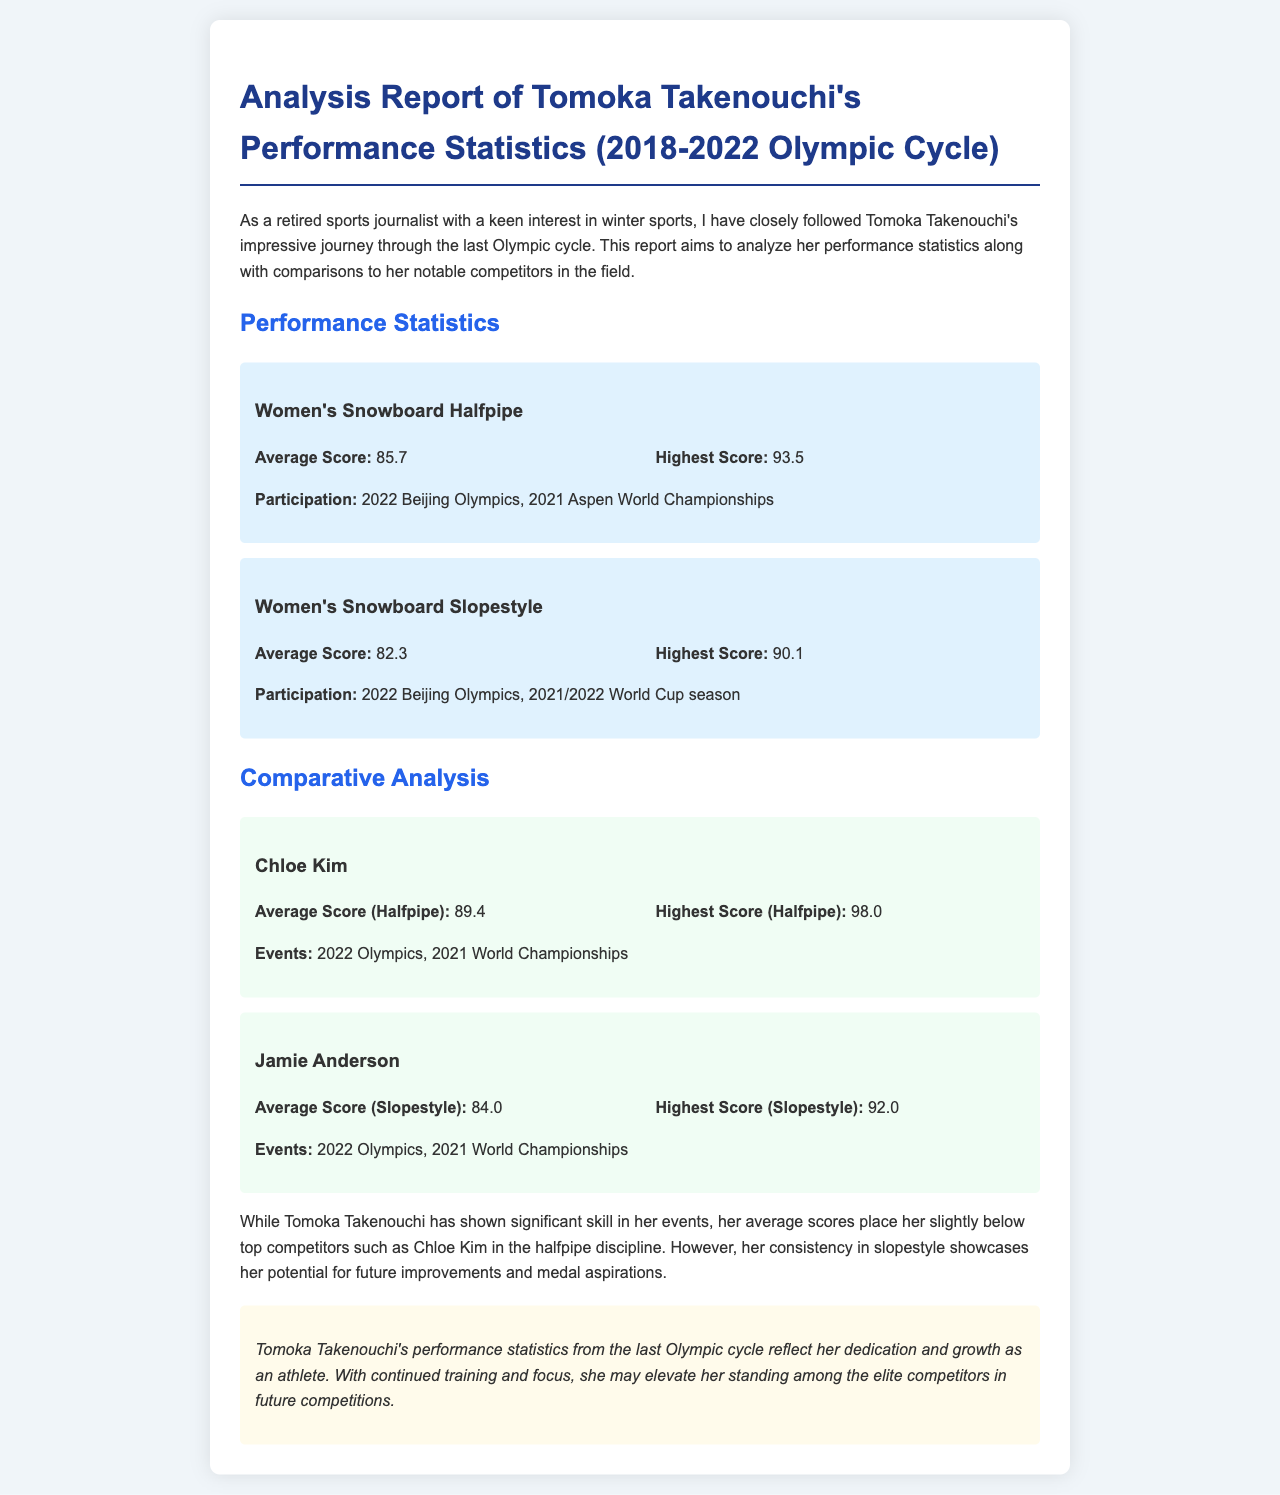What is Tomoka Takenouchi's highest score in Women's Snowboard Halfpipe? The highest score is specified in the document under the Women's Snowboard Halfpipe section, which is 93.5.
Answer: 93.5 What was Tomoka Takenouchi's average score in Women's Snowboard Slopestyle? The average score is detailed in the Women's Snowboard Slopestyle section, which is 82.3.
Answer: 82.3 Who is compared to Tomoka Takenouchi in the halfpipe discipline? The document names Chloe Kim as a competitor in the halfpipe discipline when comparing performance statistics.
Answer: Chloe Kim What is Chloe Kim's highest score in halfpipe? The document lists Chloe Kim's highest score in the halfpipe discipline as 98.0.
Answer: 98.0 How many events did Jamie Anderson participate in, according to the document? The document mentions events for Jamie Anderson, specifically the 2022 Olympics and the 2021 World Championships, indicating she participated in two events.
Answer: 2 Which competition does Tomoka Takenouchi's highest score refer to? The highest score of 93.5 in Women's Snowboard Halfpipe is achieved during the 2022 Beijing Olympics and the 2021 Aspen World Championships.
Answer: 2022 Beijing Olympics What conclusion is drawn about Tomoka Takenouchi's performance? The concluding statement in the document reflects that her performance statistics showcase her dedication and growth, implying potential for further improvement.
Answer: Dedication and growth What color scheme is used for the document's background? The document describes the background color as a light shade, specifically #f0f5f9, which gives it a soft overall appearance.
Answer: Light blue 